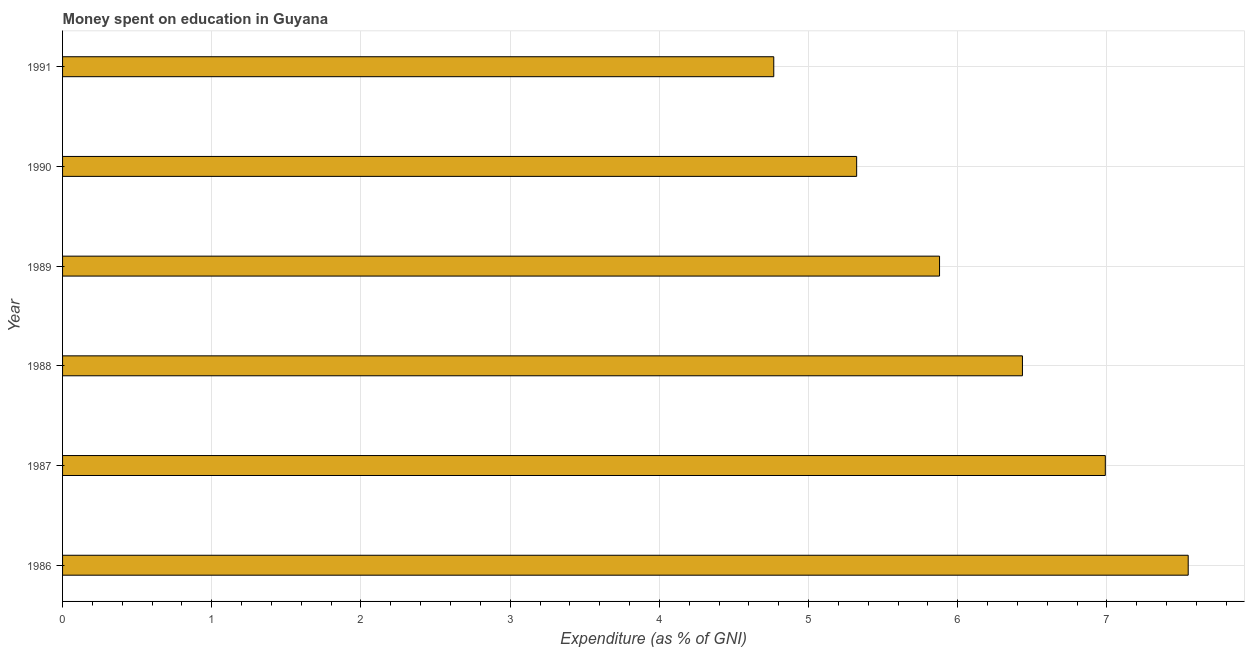Does the graph contain grids?
Your response must be concise. Yes. What is the title of the graph?
Provide a short and direct response. Money spent on education in Guyana. What is the label or title of the X-axis?
Ensure brevity in your answer.  Expenditure (as % of GNI). What is the expenditure on education in 1988?
Keep it short and to the point. 6.43. Across all years, what is the maximum expenditure on education?
Ensure brevity in your answer.  7.54. Across all years, what is the minimum expenditure on education?
Keep it short and to the point. 4.77. In which year was the expenditure on education maximum?
Your response must be concise. 1986. In which year was the expenditure on education minimum?
Your response must be concise. 1991. What is the sum of the expenditure on education?
Provide a short and direct response. 36.93. What is the difference between the expenditure on education in 1986 and 1988?
Provide a succinct answer. 1.11. What is the average expenditure on education per year?
Your response must be concise. 6.16. What is the median expenditure on education?
Give a very brief answer. 6.16. What is the ratio of the expenditure on education in 1987 to that in 1988?
Your answer should be very brief. 1.09. Is the expenditure on education in 1986 less than that in 1988?
Your answer should be very brief. No. Is the difference between the expenditure on education in 1986 and 1988 greater than the difference between any two years?
Your answer should be compact. No. What is the difference between the highest and the second highest expenditure on education?
Your answer should be compact. 0.56. Is the sum of the expenditure on education in 1989 and 1991 greater than the maximum expenditure on education across all years?
Keep it short and to the point. Yes. What is the difference between the highest and the lowest expenditure on education?
Keep it short and to the point. 2.78. In how many years, is the expenditure on education greater than the average expenditure on education taken over all years?
Ensure brevity in your answer.  3. How many bars are there?
Provide a short and direct response. 6. Are all the bars in the graph horizontal?
Provide a succinct answer. Yes. How many years are there in the graph?
Provide a short and direct response. 6. What is the difference between two consecutive major ticks on the X-axis?
Your response must be concise. 1. Are the values on the major ticks of X-axis written in scientific E-notation?
Give a very brief answer. No. What is the Expenditure (as % of GNI) of 1986?
Make the answer very short. 7.54. What is the Expenditure (as % of GNI) of 1987?
Your answer should be very brief. 6.99. What is the Expenditure (as % of GNI) in 1988?
Your response must be concise. 6.43. What is the Expenditure (as % of GNI) of 1989?
Keep it short and to the point. 5.88. What is the Expenditure (as % of GNI) in 1990?
Your response must be concise. 5.32. What is the Expenditure (as % of GNI) of 1991?
Provide a short and direct response. 4.77. What is the difference between the Expenditure (as % of GNI) in 1986 and 1987?
Your answer should be very brief. 0.56. What is the difference between the Expenditure (as % of GNI) in 1986 and 1988?
Your response must be concise. 1.11. What is the difference between the Expenditure (as % of GNI) in 1986 and 1989?
Provide a succinct answer. 1.67. What is the difference between the Expenditure (as % of GNI) in 1986 and 1990?
Provide a succinct answer. 2.22. What is the difference between the Expenditure (as % of GNI) in 1986 and 1991?
Provide a succinct answer. 2.78. What is the difference between the Expenditure (as % of GNI) in 1987 and 1988?
Your answer should be compact. 0.56. What is the difference between the Expenditure (as % of GNI) in 1987 and 1989?
Provide a short and direct response. 1.11. What is the difference between the Expenditure (as % of GNI) in 1987 and 1990?
Ensure brevity in your answer.  1.67. What is the difference between the Expenditure (as % of GNI) in 1987 and 1991?
Give a very brief answer. 2.22. What is the difference between the Expenditure (as % of GNI) in 1988 and 1989?
Your answer should be compact. 0.56. What is the difference between the Expenditure (as % of GNI) in 1988 and 1990?
Provide a succinct answer. 1.11. What is the difference between the Expenditure (as % of GNI) in 1988 and 1991?
Ensure brevity in your answer.  1.67. What is the difference between the Expenditure (as % of GNI) in 1989 and 1990?
Offer a very short reply. 0.56. What is the difference between the Expenditure (as % of GNI) in 1989 and 1991?
Provide a short and direct response. 1.11. What is the difference between the Expenditure (as % of GNI) in 1990 and 1991?
Give a very brief answer. 0.56. What is the ratio of the Expenditure (as % of GNI) in 1986 to that in 1987?
Offer a terse response. 1.08. What is the ratio of the Expenditure (as % of GNI) in 1986 to that in 1988?
Give a very brief answer. 1.17. What is the ratio of the Expenditure (as % of GNI) in 1986 to that in 1989?
Keep it short and to the point. 1.28. What is the ratio of the Expenditure (as % of GNI) in 1986 to that in 1990?
Your answer should be very brief. 1.42. What is the ratio of the Expenditure (as % of GNI) in 1986 to that in 1991?
Give a very brief answer. 1.58. What is the ratio of the Expenditure (as % of GNI) in 1987 to that in 1988?
Your answer should be compact. 1.09. What is the ratio of the Expenditure (as % of GNI) in 1987 to that in 1989?
Your response must be concise. 1.19. What is the ratio of the Expenditure (as % of GNI) in 1987 to that in 1990?
Your answer should be compact. 1.31. What is the ratio of the Expenditure (as % of GNI) in 1987 to that in 1991?
Provide a short and direct response. 1.47. What is the ratio of the Expenditure (as % of GNI) in 1988 to that in 1989?
Provide a succinct answer. 1.09. What is the ratio of the Expenditure (as % of GNI) in 1988 to that in 1990?
Your answer should be very brief. 1.21. What is the ratio of the Expenditure (as % of GNI) in 1988 to that in 1991?
Keep it short and to the point. 1.35. What is the ratio of the Expenditure (as % of GNI) in 1989 to that in 1990?
Your answer should be very brief. 1.1. What is the ratio of the Expenditure (as % of GNI) in 1989 to that in 1991?
Ensure brevity in your answer.  1.23. What is the ratio of the Expenditure (as % of GNI) in 1990 to that in 1991?
Your answer should be compact. 1.12. 